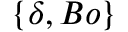Convert formula to latex. <formula><loc_0><loc_0><loc_500><loc_500>\{ \delta , B o \}</formula> 